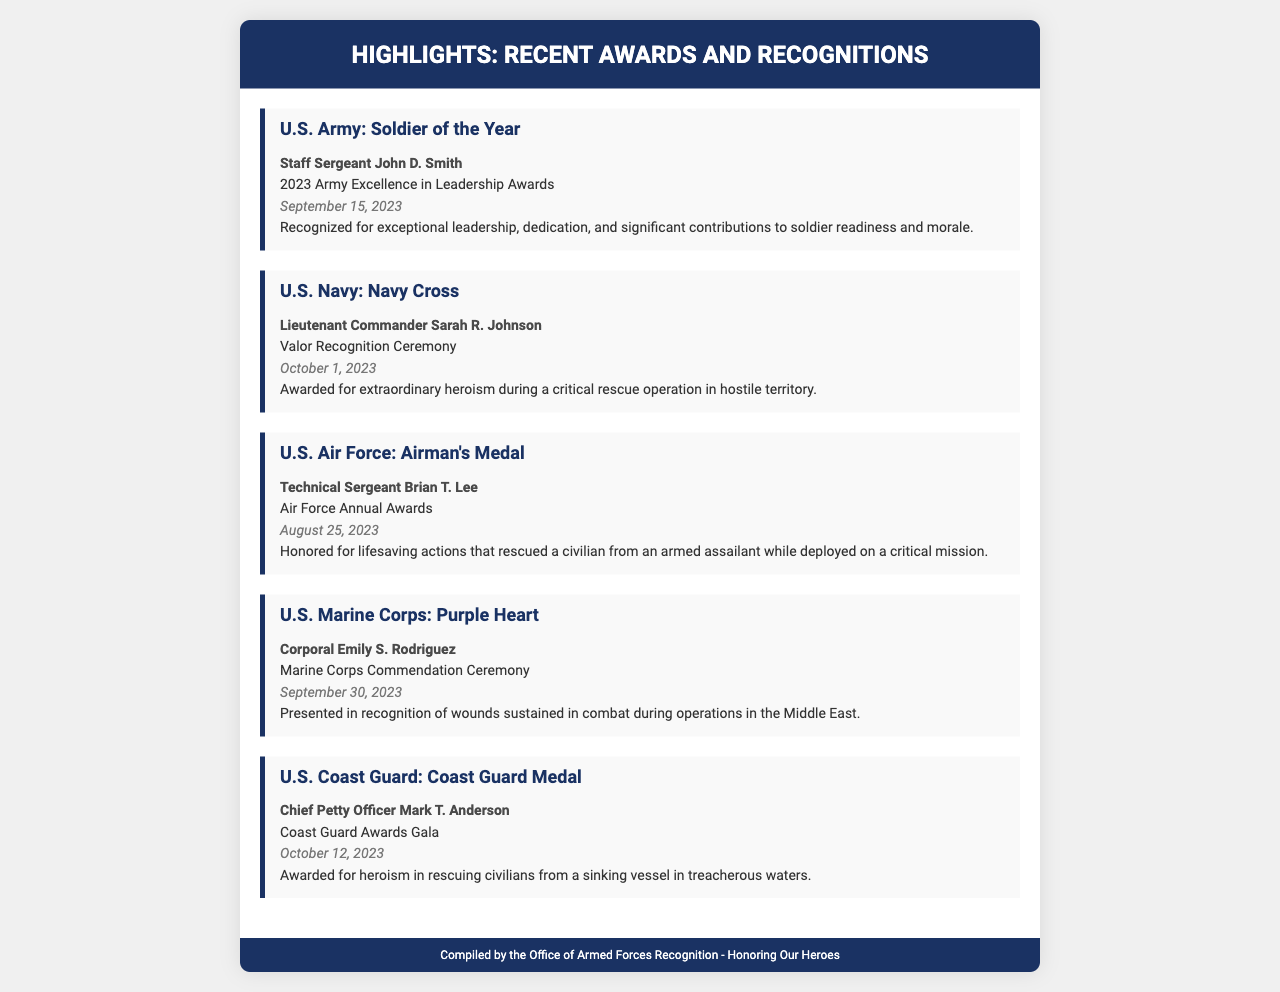What award did Staff Sergeant John D. Smith receive? The document states that Staff Sergeant John D. Smith was awarded the Soldier of the Year.
Answer: Soldier of the Year When was Lieutenant Commander Sarah R. Johnson recognized? The date of recognition for Lieutenant Commander Sarah R. Johnson is mentioned as October 1, 2023.
Answer: October 1, 2023 What significant action did Technical Sergeant Brian T. Lee perform? The document describes his honorary action as lifesaving actions that rescued a civilian from an armed assailant.
Answer: Lifesaving actions Which branch did Corporal Emily S. Rodriguez belong to? The document identifies Corporal Emily S. Rodriguez as a member of the U.S. Marine Corps.
Answer: U.S. Marine Corps What type of recognition did Chief Petty Officer Mark T. Anderson receive? The document states that Chief Petty Officer Mark T. Anderson received the Coast Guard Medal.
Answer: Coast Guard Medal What was the date of the Army Excellence in Leadership Awards? The date for the Army Excellence in Leadership Awards is specified as September 15, 2023.
Answer: September 15, 2023 What common theme is highlighted in the document? The document highlights awards and recognitions for service members across various branches of the armed forces.
Answer: Awards and recognitions How many awards are listed in the document? The document lists a total of five awards presented to service members from different branches.
Answer: Five What does the footer of the document indicate? The footer identifies the source of the document as the Office of Armed Forces Recognition.
Answer: Office of Armed Forces Recognition 